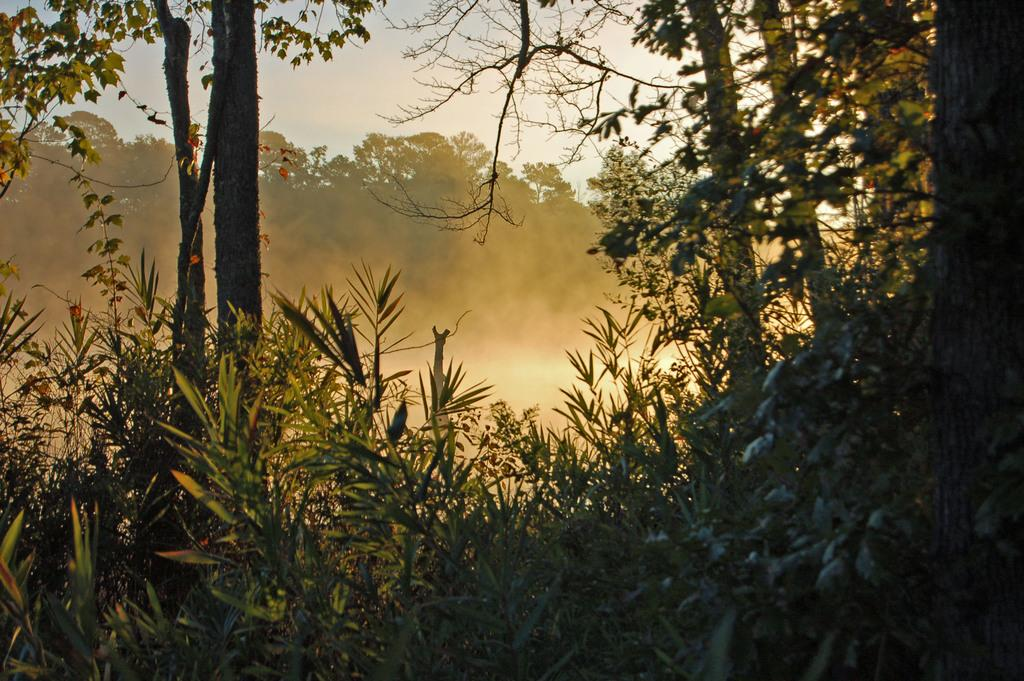What type of vegetation can be seen in the image? There are plants and trees in the image. Can you describe the trees in the image? There are trees in the image, and some of them are visible in the background. What can be seen in the background of the image? The sky is visible in the background of the image. What condition is the neck of the tree in the image? There is no mention of a tree's neck in the image, as trees do not have necks. 